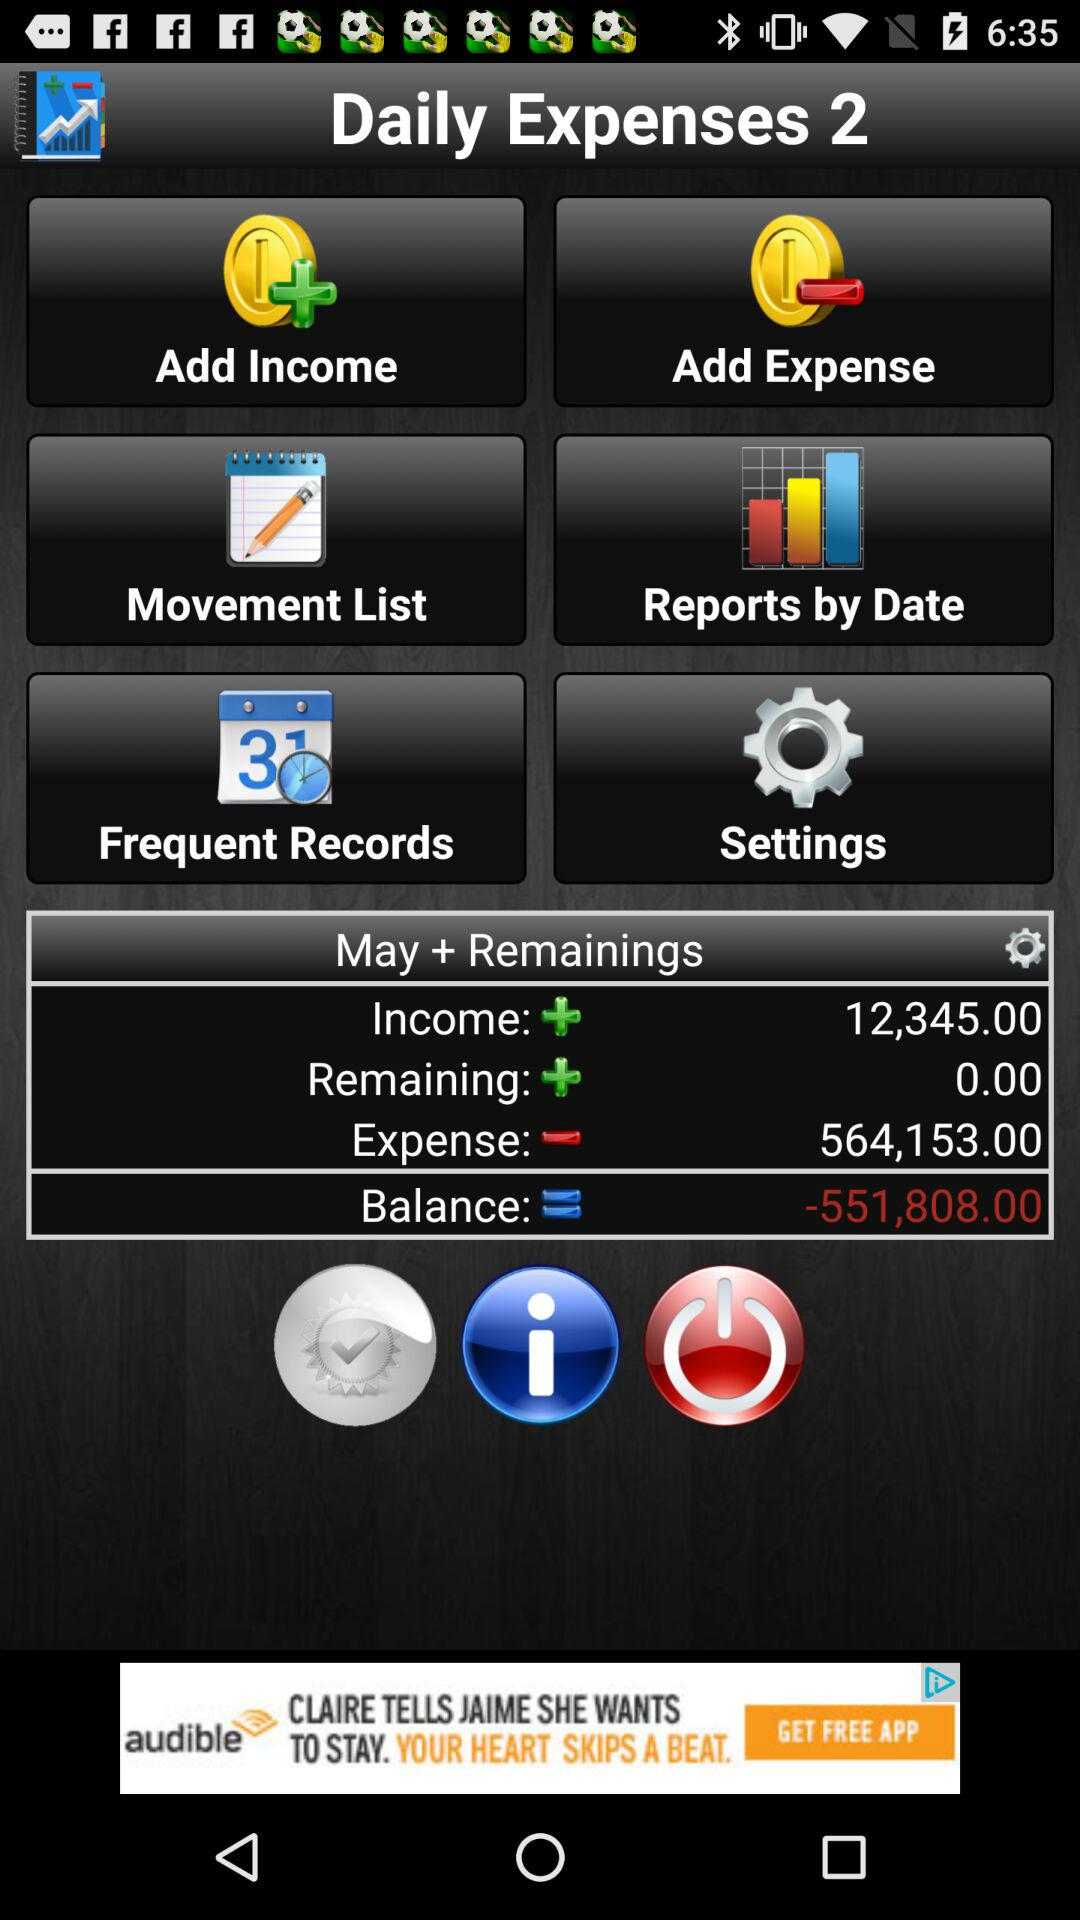What is the remaining amount? The remaining amount is zero. 